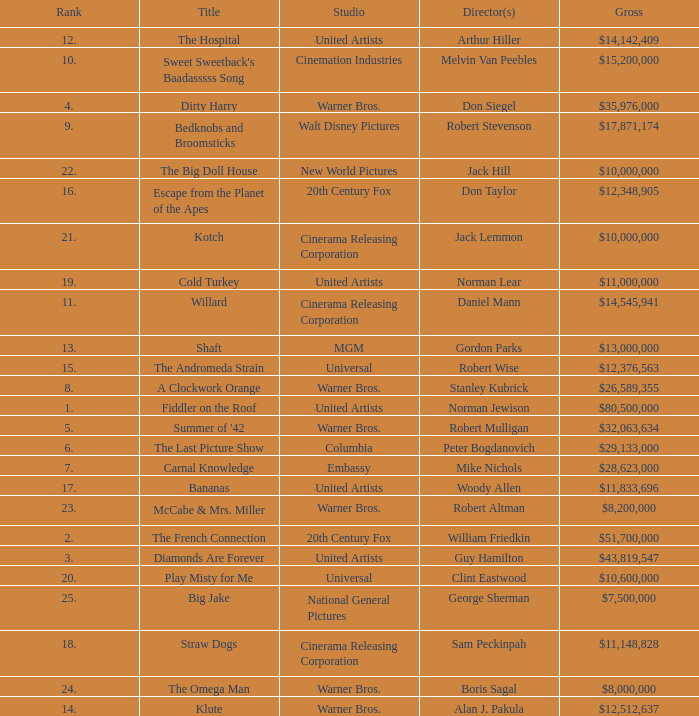Parse the full table. {'header': ['Rank', 'Title', 'Studio', 'Director(s)', 'Gross'], 'rows': [['12.', 'The Hospital', 'United Artists', 'Arthur Hiller', '$14,142,409'], ['10.', "Sweet Sweetback's Baadasssss Song", 'Cinemation Industries', 'Melvin Van Peebles', '$15,200,000'], ['4.', 'Dirty Harry', 'Warner Bros.', 'Don Siegel', '$35,976,000'], ['9.', 'Bedknobs and Broomsticks', 'Walt Disney Pictures', 'Robert Stevenson', '$17,871,174'], ['22.', 'The Big Doll House', 'New World Pictures', 'Jack Hill', '$10,000,000'], ['16.', 'Escape from the Planet of the Apes', '20th Century Fox', 'Don Taylor', '$12,348,905'], ['21.', 'Kotch', 'Cinerama Releasing Corporation', 'Jack Lemmon', '$10,000,000'], ['19.', 'Cold Turkey', 'United Artists', 'Norman Lear', '$11,000,000'], ['11.', 'Willard', 'Cinerama Releasing Corporation', 'Daniel Mann', '$14,545,941'], ['13.', 'Shaft', 'MGM', 'Gordon Parks', '$13,000,000'], ['15.', 'The Andromeda Strain', 'Universal', 'Robert Wise', '$12,376,563'], ['8.', 'A Clockwork Orange', 'Warner Bros.', 'Stanley Kubrick', '$26,589,355'], ['1.', 'Fiddler on the Roof', 'United Artists', 'Norman Jewison', '$80,500,000'], ['5.', "Summer of '42", 'Warner Bros.', 'Robert Mulligan', '$32,063,634'], ['6.', 'The Last Picture Show', 'Columbia', 'Peter Bogdanovich', '$29,133,000'], ['7.', 'Carnal Knowledge', 'Embassy', 'Mike Nichols', '$28,623,000'], ['17.', 'Bananas', 'United Artists', 'Woody Allen', '$11,833,696'], ['23.', 'McCabe & Mrs. Miller', 'Warner Bros.', 'Robert Altman', '$8,200,000'], ['2.', 'The French Connection', '20th Century Fox', 'William Friedkin', '$51,700,000'], ['3.', 'Diamonds Are Forever', 'United Artists', 'Guy Hamilton', '$43,819,547'], ['20.', 'Play Misty for Me', 'Universal', 'Clint Eastwood', '$10,600,000'], ['25.', 'Big Jake', 'National General Pictures', 'George Sherman', '$7,500,000'], ['18.', 'Straw Dogs', 'Cinerama Releasing Corporation', 'Sam Peckinpah', '$11,148,828'], ['24.', 'The Omega Man', 'Warner Bros.', 'Boris Sagal', '$8,000,000'], ['14.', 'Klute', 'Warner Bros.', 'Alan J. Pakula', '$12,512,637']]} What is the rank of The Big Doll House? 22.0. 